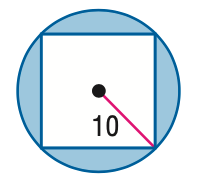Question: Find the area of the shaded region. Assume that all polygons that appear to be regular are regular. Round to the nearest tenth.
Choices:
A. 114.2
B. 214.2
C. 264.2
D. 314.2
Answer with the letter. Answer: A 